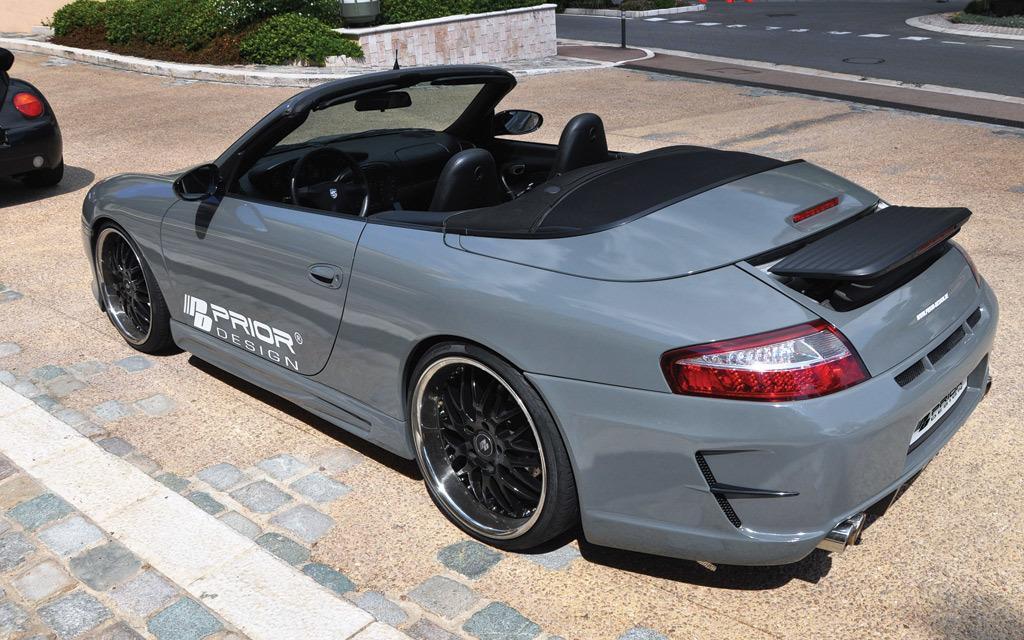How would you summarize this image in a sentence or two? In the picture there are two cars in the parking,near to car there is a road near to the road there are plants on the car there is some text. 